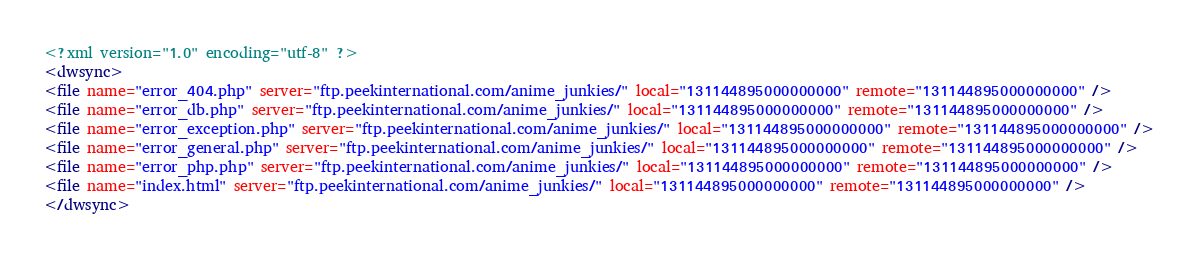<code> <loc_0><loc_0><loc_500><loc_500><_XML_><?xml version="1.0" encoding="utf-8" ?>
<dwsync>
<file name="error_404.php" server="ftp.peekinternational.com/anime_junkies/" local="131144895000000000" remote="131144895000000000" />
<file name="error_db.php" server="ftp.peekinternational.com/anime_junkies/" local="131144895000000000" remote="131144895000000000" />
<file name="error_exception.php" server="ftp.peekinternational.com/anime_junkies/" local="131144895000000000" remote="131144895000000000" />
<file name="error_general.php" server="ftp.peekinternational.com/anime_junkies/" local="131144895000000000" remote="131144895000000000" />
<file name="error_php.php" server="ftp.peekinternational.com/anime_junkies/" local="131144895000000000" remote="131144895000000000" />
<file name="index.html" server="ftp.peekinternational.com/anime_junkies/" local="131144895000000000" remote="131144895000000000" />
</dwsync></code> 